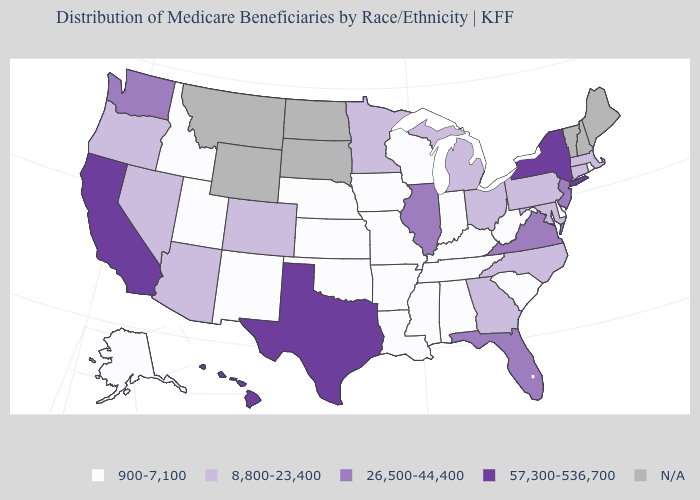What is the highest value in the USA?
Answer briefly. 57,300-536,700. What is the value of Tennessee?
Be succinct. 900-7,100. Is the legend a continuous bar?
Be succinct. No. Name the states that have a value in the range 57,300-536,700?
Short answer required. California, Hawaii, New York, Texas. Name the states that have a value in the range 900-7,100?
Short answer required. Alabama, Alaska, Arkansas, Delaware, Idaho, Indiana, Iowa, Kansas, Kentucky, Louisiana, Mississippi, Missouri, Nebraska, New Mexico, Oklahoma, Rhode Island, South Carolina, Tennessee, Utah, West Virginia, Wisconsin. Which states have the highest value in the USA?
Give a very brief answer. California, Hawaii, New York, Texas. Does Michigan have the lowest value in the MidWest?
Write a very short answer. No. Does New Jersey have the highest value in the Northeast?
Keep it brief. No. Among the states that border Georgia , does Alabama have the lowest value?
Short answer required. Yes. Name the states that have a value in the range 26,500-44,400?
Answer briefly. Florida, Illinois, New Jersey, Virginia, Washington. Among the states that border Iowa , which have the lowest value?
Write a very short answer. Missouri, Nebraska, Wisconsin. Among the states that border Kansas , does Nebraska have the lowest value?
Concise answer only. Yes. What is the lowest value in states that border Maryland?
Keep it brief. 900-7,100. How many symbols are there in the legend?
Write a very short answer. 5. 